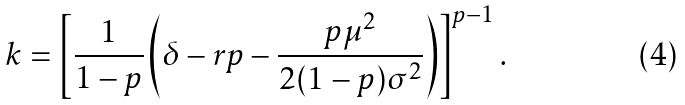<formula> <loc_0><loc_0><loc_500><loc_500>k = \left [ \frac { 1 } { 1 - p } \left ( \delta - r p - \frac { p \mu ^ { 2 } } { 2 ( 1 - p ) \sigma ^ { 2 } } \right ) \right ] ^ { p - 1 } .</formula> 